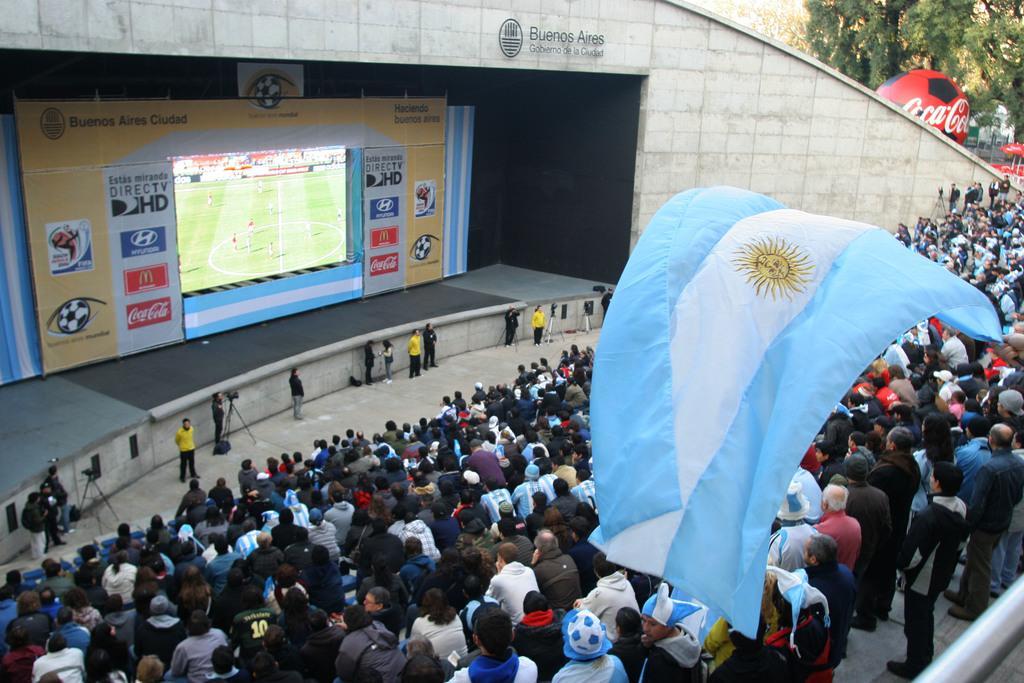In one or two sentences, can you explain what this image depicts? In this image we can see a group of people on the ground, some people are standing. In the center of the image we can see some cameras placed on stands, a screen and board with some text. On the right side of the image we can see a hand of a person holding flag, a pole, some trees and a ball. At the top of the image we can see a wall. 